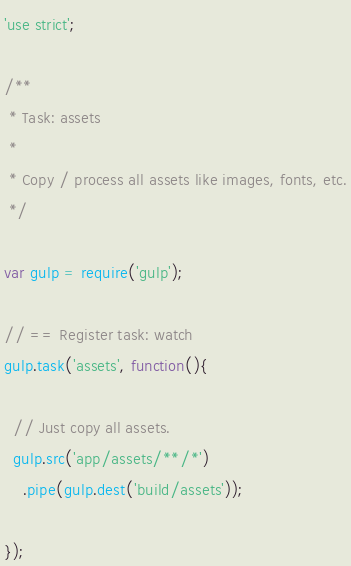<code> <loc_0><loc_0><loc_500><loc_500><_JavaScript_>'use strict';

/**
 * Task: assets 
 *
 * Copy / process all assets like images, fonts, etc.
 */

var gulp = require('gulp');

// == Register task: watch
gulp.task('assets', function(){
  
  // Just copy all assets.
  gulp.src('app/assets/**/*')
    .pipe(gulp.dest('build/assets'));

});

</code> 